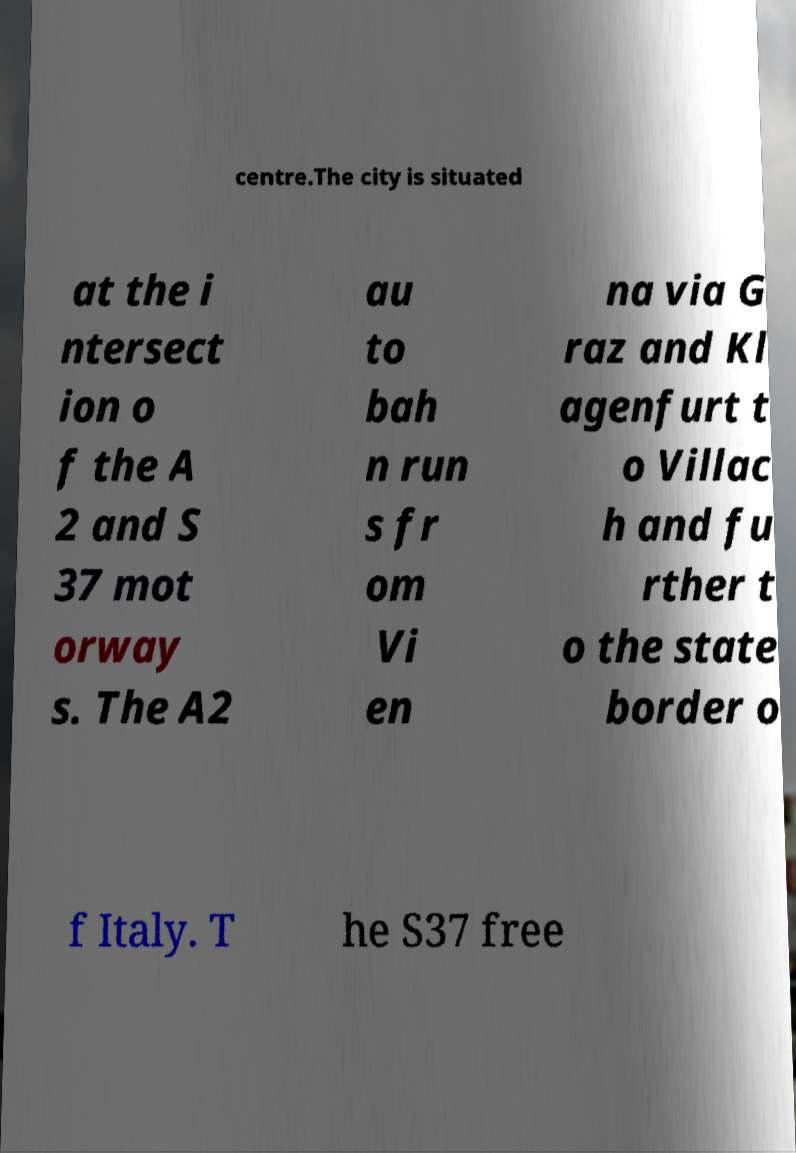Can you read and provide the text displayed in the image?This photo seems to have some interesting text. Can you extract and type it out for me? centre.The city is situated at the i ntersect ion o f the A 2 and S 37 mot orway s. The A2 au to bah n run s fr om Vi en na via G raz and Kl agenfurt t o Villac h and fu rther t o the state border o f Italy. T he S37 free 